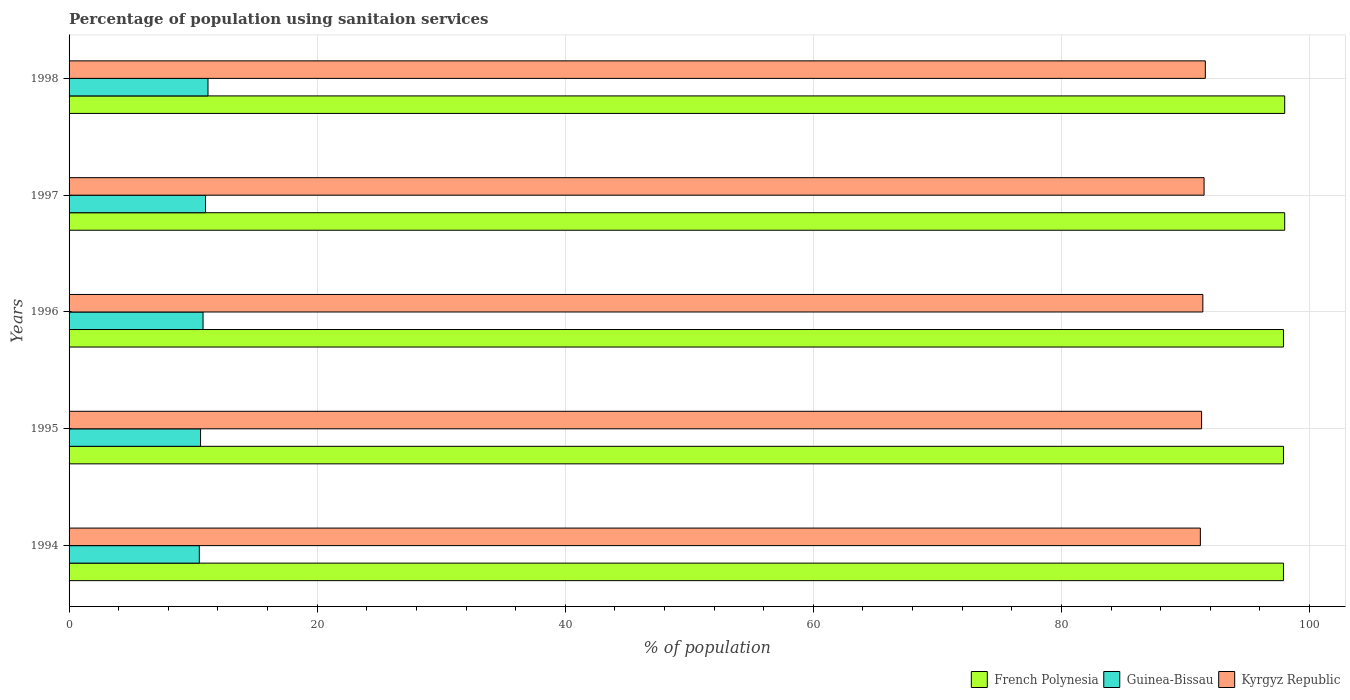How many different coloured bars are there?
Give a very brief answer. 3. Are the number of bars on each tick of the Y-axis equal?
Keep it short and to the point. Yes. What is the label of the 3rd group of bars from the top?
Provide a succinct answer. 1996. In how many cases, is the number of bars for a given year not equal to the number of legend labels?
Offer a very short reply. 0. What is the percentage of population using sanitaion services in Kyrgyz Republic in 1994?
Offer a terse response. 91.2. Across all years, what is the maximum percentage of population using sanitaion services in Kyrgyz Republic?
Ensure brevity in your answer.  91.6. Across all years, what is the minimum percentage of population using sanitaion services in French Polynesia?
Your answer should be very brief. 97.9. What is the total percentage of population using sanitaion services in Guinea-Bissau in the graph?
Make the answer very short. 54.1. What is the difference between the percentage of population using sanitaion services in French Polynesia in 1995 and that in 1996?
Keep it short and to the point. 0. What is the difference between the percentage of population using sanitaion services in Kyrgyz Republic in 1996 and the percentage of population using sanitaion services in Guinea-Bissau in 1997?
Provide a succinct answer. 80.4. What is the average percentage of population using sanitaion services in Kyrgyz Republic per year?
Offer a very short reply. 91.4. In the year 1996, what is the difference between the percentage of population using sanitaion services in Kyrgyz Republic and percentage of population using sanitaion services in French Polynesia?
Your answer should be compact. -6.5. In how many years, is the percentage of population using sanitaion services in Kyrgyz Republic greater than 80 %?
Offer a very short reply. 5. What is the ratio of the percentage of population using sanitaion services in Kyrgyz Republic in 1994 to that in 1998?
Ensure brevity in your answer.  1. Is the percentage of population using sanitaion services in French Polynesia in 1995 less than that in 1996?
Your answer should be compact. No. What is the difference between the highest and the second highest percentage of population using sanitaion services in Kyrgyz Republic?
Your answer should be very brief. 0.1. What is the difference between the highest and the lowest percentage of population using sanitaion services in Guinea-Bissau?
Give a very brief answer. 0.7. In how many years, is the percentage of population using sanitaion services in Kyrgyz Republic greater than the average percentage of population using sanitaion services in Kyrgyz Republic taken over all years?
Offer a terse response. 2. Is the sum of the percentage of population using sanitaion services in French Polynesia in 1995 and 1998 greater than the maximum percentage of population using sanitaion services in Kyrgyz Republic across all years?
Provide a short and direct response. Yes. What does the 2nd bar from the top in 1995 represents?
Provide a short and direct response. Guinea-Bissau. What does the 1st bar from the bottom in 1996 represents?
Offer a very short reply. French Polynesia. Are all the bars in the graph horizontal?
Provide a succinct answer. Yes. Are the values on the major ticks of X-axis written in scientific E-notation?
Give a very brief answer. No. Does the graph contain any zero values?
Make the answer very short. No. Does the graph contain grids?
Provide a short and direct response. Yes. Where does the legend appear in the graph?
Offer a very short reply. Bottom right. How many legend labels are there?
Provide a short and direct response. 3. What is the title of the graph?
Provide a succinct answer. Percentage of population using sanitaion services. What is the label or title of the X-axis?
Keep it short and to the point. % of population. What is the % of population of French Polynesia in 1994?
Provide a short and direct response. 97.9. What is the % of population of Kyrgyz Republic in 1994?
Keep it short and to the point. 91.2. What is the % of population in French Polynesia in 1995?
Provide a succinct answer. 97.9. What is the % of population of Guinea-Bissau in 1995?
Provide a short and direct response. 10.6. What is the % of population in Kyrgyz Republic in 1995?
Make the answer very short. 91.3. What is the % of population in French Polynesia in 1996?
Offer a terse response. 97.9. What is the % of population of Kyrgyz Republic in 1996?
Ensure brevity in your answer.  91.4. What is the % of population in Kyrgyz Republic in 1997?
Make the answer very short. 91.5. What is the % of population in French Polynesia in 1998?
Keep it short and to the point. 98. What is the % of population of Guinea-Bissau in 1998?
Your answer should be very brief. 11.2. What is the % of population in Kyrgyz Republic in 1998?
Offer a very short reply. 91.6. Across all years, what is the maximum % of population in French Polynesia?
Ensure brevity in your answer.  98. Across all years, what is the maximum % of population of Kyrgyz Republic?
Offer a terse response. 91.6. Across all years, what is the minimum % of population in French Polynesia?
Keep it short and to the point. 97.9. Across all years, what is the minimum % of population in Guinea-Bissau?
Provide a succinct answer. 10.5. Across all years, what is the minimum % of population in Kyrgyz Republic?
Give a very brief answer. 91.2. What is the total % of population in French Polynesia in the graph?
Your answer should be compact. 489.7. What is the total % of population in Guinea-Bissau in the graph?
Offer a very short reply. 54.1. What is the total % of population of Kyrgyz Republic in the graph?
Make the answer very short. 457. What is the difference between the % of population in French Polynesia in 1994 and that in 1995?
Provide a short and direct response. 0. What is the difference between the % of population of French Polynesia in 1994 and that in 1996?
Provide a short and direct response. 0. What is the difference between the % of population in Guinea-Bissau in 1994 and that in 1996?
Your answer should be compact. -0.3. What is the difference between the % of population in Kyrgyz Republic in 1994 and that in 1996?
Offer a terse response. -0.2. What is the difference between the % of population of Guinea-Bissau in 1994 and that in 1997?
Keep it short and to the point. -0.5. What is the difference between the % of population of Kyrgyz Republic in 1994 and that in 1997?
Your response must be concise. -0.3. What is the difference between the % of population of French Polynesia in 1994 and that in 1998?
Offer a very short reply. -0.1. What is the difference between the % of population of French Polynesia in 1995 and that in 1996?
Offer a terse response. 0. What is the difference between the % of population of Guinea-Bissau in 1995 and that in 1997?
Your answer should be compact. -0.4. What is the difference between the % of population of French Polynesia in 1995 and that in 1998?
Keep it short and to the point. -0.1. What is the difference between the % of population in Kyrgyz Republic in 1996 and that in 1997?
Provide a succinct answer. -0.1. What is the difference between the % of population in French Polynesia in 1996 and that in 1998?
Provide a succinct answer. -0.1. What is the difference between the % of population in Guinea-Bissau in 1997 and that in 1998?
Provide a short and direct response. -0.2. What is the difference between the % of population of French Polynesia in 1994 and the % of population of Guinea-Bissau in 1995?
Your response must be concise. 87.3. What is the difference between the % of population in Guinea-Bissau in 1994 and the % of population in Kyrgyz Republic in 1995?
Make the answer very short. -80.8. What is the difference between the % of population in French Polynesia in 1994 and the % of population in Guinea-Bissau in 1996?
Give a very brief answer. 87.1. What is the difference between the % of population of French Polynesia in 1994 and the % of population of Kyrgyz Republic in 1996?
Your answer should be very brief. 6.5. What is the difference between the % of population of Guinea-Bissau in 1994 and the % of population of Kyrgyz Republic in 1996?
Provide a succinct answer. -80.9. What is the difference between the % of population in French Polynesia in 1994 and the % of population in Guinea-Bissau in 1997?
Your answer should be compact. 86.9. What is the difference between the % of population in Guinea-Bissau in 1994 and the % of population in Kyrgyz Republic in 1997?
Your answer should be compact. -81. What is the difference between the % of population in French Polynesia in 1994 and the % of population in Guinea-Bissau in 1998?
Your answer should be compact. 86.7. What is the difference between the % of population of Guinea-Bissau in 1994 and the % of population of Kyrgyz Republic in 1998?
Your answer should be very brief. -81.1. What is the difference between the % of population of French Polynesia in 1995 and the % of population of Guinea-Bissau in 1996?
Keep it short and to the point. 87.1. What is the difference between the % of population in Guinea-Bissau in 1995 and the % of population in Kyrgyz Republic in 1996?
Your answer should be very brief. -80.8. What is the difference between the % of population in French Polynesia in 1995 and the % of population in Guinea-Bissau in 1997?
Offer a terse response. 86.9. What is the difference between the % of population of French Polynesia in 1995 and the % of population of Kyrgyz Republic in 1997?
Make the answer very short. 6.4. What is the difference between the % of population in Guinea-Bissau in 1995 and the % of population in Kyrgyz Republic in 1997?
Keep it short and to the point. -80.9. What is the difference between the % of population of French Polynesia in 1995 and the % of population of Guinea-Bissau in 1998?
Offer a terse response. 86.7. What is the difference between the % of population in Guinea-Bissau in 1995 and the % of population in Kyrgyz Republic in 1998?
Make the answer very short. -81. What is the difference between the % of population in French Polynesia in 1996 and the % of population in Guinea-Bissau in 1997?
Your answer should be compact. 86.9. What is the difference between the % of population of Guinea-Bissau in 1996 and the % of population of Kyrgyz Republic in 1997?
Provide a succinct answer. -80.7. What is the difference between the % of population of French Polynesia in 1996 and the % of population of Guinea-Bissau in 1998?
Ensure brevity in your answer.  86.7. What is the difference between the % of population of French Polynesia in 1996 and the % of population of Kyrgyz Republic in 1998?
Your answer should be very brief. 6.3. What is the difference between the % of population in Guinea-Bissau in 1996 and the % of population in Kyrgyz Republic in 1998?
Provide a succinct answer. -80.8. What is the difference between the % of population of French Polynesia in 1997 and the % of population of Guinea-Bissau in 1998?
Your answer should be very brief. 86.8. What is the difference between the % of population of French Polynesia in 1997 and the % of population of Kyrgyz Republic in 1998?
Your answer should be very brief. 6.4. What is the difference between the % of population in Guinea-Bissau in 1997 and the % of population in Kyrgyz Republic in 1998?
Your response must be concise. -80.6. What is the average % of population in French Polynesia per year?
Make the answer very short. 97.94. What is the average % of population in Guinea-Bissau per year?
Provide a short and direct response. 10.82. What is the average % of population in Kyrgyz Republic per year?
Your answer should be very brief. 91.4. In the year 1994, what is the difference between the % of population of French Polynesia and % of population of Guinea-Bissau?
Provide a short and direct response. 87.4. In the year 1994, what is the difference between the % of population in Guinea-Bissau and % of population in Kyrgyz Republic?
Ensure brevity in your answer.  -80.7. In the year 1995, what is the difference between the % of population of French Polynesia and % of population of Guinea-Bissau?
Give a very brief answer. 87.3. In the year 1995, what is the difference between the % of population of French Polynesia and % of population of Kyrgyz Republic?
Your answer should be very brief. 6.6. In the year 1995, what is the difference between the % of population of Guinea-Bissau and % of population of Kyrgyz Republic?
Provide a succinct answer. -80.7. In the year 1996, what is the difference between the % of population of French Polynesia and % of population of Guinea-Bissau?
Give a very brief answer. 87.1. In the year 1996, what is the difference between the % of population of French Polynesia and % of population of Kyrgyz Republic?
Your response must be concise. 6.5. In the year 1996, what is the difference between the % of population of Guinea-Bissau and % of population of Kyrgyz Republic?
Provide a succinct answer. -80.6. In the year 1997, what is the difference between the % of population in French Polynesia and % of population in Guinea-Bissau?
Offer a very short reply. 87. In the year 1997, what is the difference between the % of population of French Polynesia and % of population of Kyrgyz Republic?
Your answer should be very brief. 6.5. In the year 1997, what is the difference between the % of population in Guinea-Bissau and % of population in Kyrgyz Republic?
Provide a succinct answer. -80.5. In the year 1998, what is the difference between the % of population in French Polynesia and % of population in Guinea-Bissau?
Make the answer very short. 86.8. In the year 1998, what is the difference between the % of population in Guinea-Bissau and % of population in Kyrgyz Republic?
Give a very brief answer. -80.4. What is the ratio of the % of population of French Polynesia in 1994 to that in 1995?
Give a very brief answer. 1. What is the ratio of the % of population of Guinea-Bissau in 1994 to that in 1995?
Keep it short and to the point. 0.99. What is the ratio of the % of population of Guinea-Bissau in 1994 to that in 1996?
Ensure brevity in your answer.  0.97. What is the ratio of the % of population in Kyrgyz Republic in 1994 to that in 1996?
Provide a short and direct response. 1. What is the ratio of the % of population in French Polynesia in 1994 to that in 1997?
Keep it short and to the point. 1. What is the ratio of the % of population in Guinea-Bissau in 1994 to that in 1997?
Your answer should be compact. 0.95. What is the ratio of the % of population of Guinea-Bissau in 1994 to that in 1998?
Your answer should be compact. 0.94. What is the ratio of the % of population of Kyrgyz Republic in 1994 to that in 1998?
Ensure brevity in your answer.  1. What is the ratio of the % of population in Guinea-Bissau in 1995 to that in 1996?
Give a very brief answer. 0.98. What is the ratio of the % of population in Guinea-Bissau in 1995 to that in 1997?
Your answer should be very brief. 0.96. What is the ratio of the % of population of Guinea-Bissau in 1995 to that in 1998?
Your answer should be compact. 0.95. What is the ratio of the % of population in Kyrgyz Republic in 1995 to that in 1998?
Provide a short and direct response. 1. What is the ratio of the % of population in French Polynesia in 1996 to that in 1997?
Provide a short and direct response. 1. What is the ratio of the % of population of Guinea-Bissau in 1996 to that in 1997?
Keep it short and to the point. 0.98. What is the ratio of the % of population of Guinea-Bissau in 1997 to that in 1998?
Provide a succinct answer. 0.98. What is the ratio of the % of population in Kyrgyz Republic in 1997 to that in 1998?
Provide a short and direct response. 1. What is the difference between the highest and the second highest % of population of French Polynesia?
Make the answer very short. 0. 